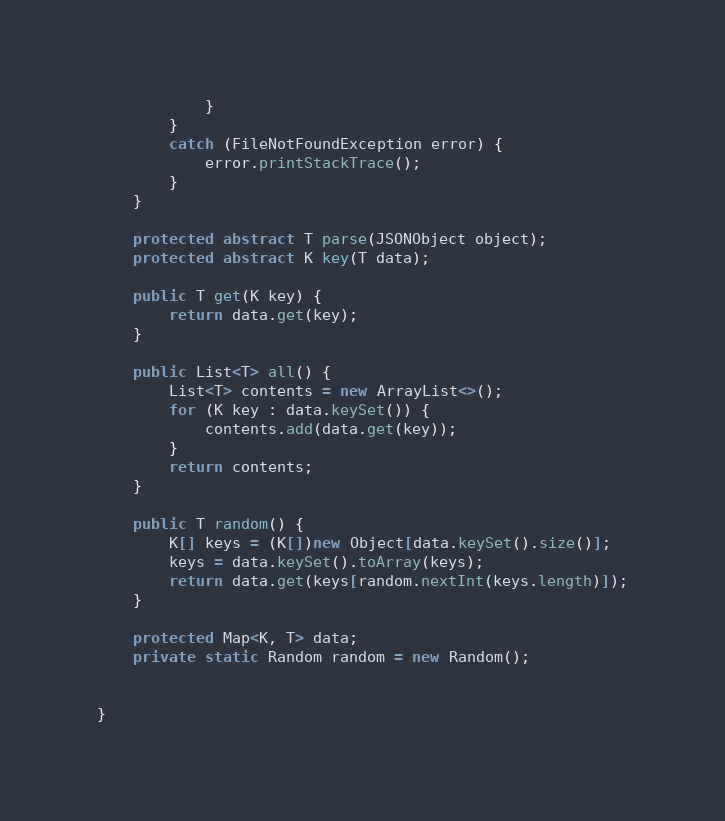<code> <loc_0><loc_0><loc_500><loc_500><_Java_>            }
        }
        catch (FileNotFoundException error) {
            error.printStackTrace();
        }
    }

    protected abstract T parse(JSONObject object);
    protected abstract K key(T data);

    public T get(K key) {
        return data.get(key);
    }

    public List<T> all() {
        List<T> contents = new ArrayList<>();
        for (K key : data.keySet()) {
            contents.add(data.get(key));
        }
        return contents;
    }

    public T random() {
        K[] keys = (K[])new Object[data.keySet().size()];
        keys = data.keySet().toArray(keys);
        return data.get(keys[random.nextInt(keys.length)]);
    }

    protected Map<K, T> data;
    private static Random random = new Random();


}
</code> 